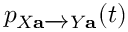<formula> <loc_0><loc_0><loc_500><loc_500>p _ { X a Y a } ( t )</formula> 